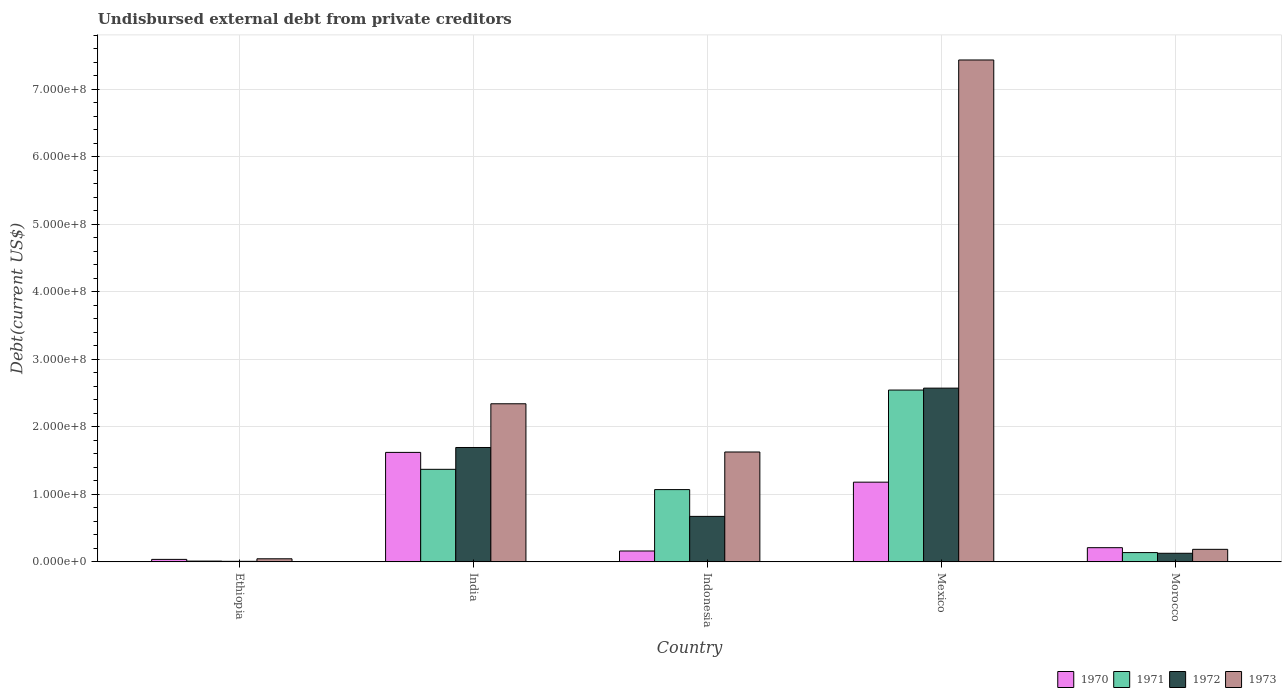How many different coloured bars are there?
Your answer should be very brief. 4. How many groups of bars are there?
Your response must be concise. 5. What is the label of the 5th group of bars from the left?
Your answer should be very brief. Morocco. In how many cases, is the number of bars for a given country not equal to the number of legend labels?
Your answer should be compact. 0. What is the total debt in 1970 in India?
Your answer should be very brief. 1.62e+08. Across all countries, what is the maximum total debt in 1970?
Your answer should be very brief. 1.62e+08. Across all countries, what is the minimum total debt in 1973?
Provide a short and direct response. 4.57e+06. In which country was the total debt in 1970 maximum?
Give a very brief answer. India. In which country was the total debt in 1970 minimum?
Provide a succinct answer. Ethiopia. What is the total total debt in 1970 in the graph?
Ensure brevity in your answer.  3.21e+08. What is the difference between the total debt in 1970 in India and that in Mexico?
Your answer should be very brief. 4.41e+07. What is the difference between the total debt in 1972 in Morocco and the total debt in 1970 in Indonesia?
Your response must be concise. -3.39e+06. What is the average total debt in 1971 per country?
Ensure brevity in your answer.  1.03e+08. What is the difference between the total debt of/in 1970 and total debt of/in 1971 in Morocco?
Make the answer very short. 7.27e+06. In how many countries, is the total debt in 1972 greater than 580000000 US$?
Offer a terse response. 0. What is the ratio of the total debt in 1970 in Ethiopia to that in Mexico?
Offer a very short reply. 0.03. Is the total debt in 1970 in Ethiopia less than that in Indonesia?
Your answer should be compact. Yes. Is the difference between the total debt in 1970 in India and Morocco greater than the difference between the total debt in 1971 in India and Morocco?
Give a very brief answer. Yes. What is the difference between the highest and the second highest total debt in 1970?
Give a very brief answer. -4.41e+07. What is the difference between the highest and the lowest total debt in 1971?
Offer a very short reply. 2.53e+08. In how many countries, is the total debt in 1973 greater than the average total debt in 1973 taken over all countries?
Your response must be concise. 2. Is the sum of the total debt in 1971 in Ethiopia and Morocco greater than the maximum total debt in 1973 across all countries?
Offer a very short reply. No. Is it the case that in every country, the sum of the total debt in 1970 and total debt in 1971 is greater than the sum of total debt in 1972 and total debt in 1973?
Give a very brief answer. No. What does the 2nd bar from the left in Ethiopia represents?
Ensure brevity in your answer.  1971. How many bars are there?
Ensure brevity in your answer.  20. Are all the bars in the graph horizontal?
Give a very brief answer. No. How many countries are there in the graph?
Offer a terse response. 5. What is the difference between two consecutive major ticks on the Y-axis?
Keep it short and to the point. 1.00e+08. Does the graph contain grids?
Offer a terse response. Yes. How are the legend labels stacked?
Provide a succinct answer. Horizontal. What is the title of the graph?
Provide a short and direct response. Undisbursed external debt from private creditors. Does "2010" appear as one of the legend labels in the graph?
Your response must be concise. No. What is the label or title of the Y-axis?
Your response must be concise. Debt(current US$). What is the Debt(current US$) in 1970 in Ethiopia?
Ensure brevity in your answer.  3.70e+06. What is the Debt(current US$) of 1971 in Ethiopia?
Provide a short and direct response. 1.16e+06. What is the Debt(current US$) in 1972 in Ethiopia?
Offer a terse response. 8.20e+05. What is the Debt(current US$) in 1973 in Ethiopia?
Offer a terse response. 4.57e+06. What is the Debt(current US$) of 1970 in India?
Make the answer very short. 1.62e+08. What is the Debt(current US$) of 1971 in India?
Provide a succinct answer. 1.37e+08. What is the Debt(current US$) in 1972 in India?
Offer a terse response. 1.69e+08. What is the Debt(current US$) in 1973 in India?
Your answer should be compact. 2.34e+08. What is the Debt(current US$) of 1970 in Indonesia?
Provide a short and direct response. 1.61e+07. What is the Debt(current US$) of 1971 in Indonesia?
Your answer should be very brief. 1.07e+08. What is the Debt(current US$) of 1972 in Indonesia?
Give a very brief answer. 6.74e+07. What is the Debt(current US$) in 1973 in Indonesia?
Offer a terse response. 1.63e+08. What is the Debt(current US$) in 1970 in Mexico?
Give a very brief answer. 1.18e+08. What is the Debt(current US$) in 1971 in Mexico?
Keep it short and to the point. 2.54e+08. What is the Debt(current US$) in 1972 in Mexico?
Your answer should be very brief. 2.57e+08. What is the Debt(current US$) in 1973 in Mexico?
Your answer should be very brief. 7.43e+08. What is the Debt(current US$) in 1970 in Morocco?
Offer a very short reply. 2.10e+07. What is the Debt(current US$) in 1971 in Morocco?
Ensure brevity in your answer.  1.37e+07. What is the Debt(current US$) of 1972 in Morocco?
Keep it short and to the point. 1.27e+07. What is the Debt(current US$) in 1973 in Morocco?
Your response must be concise. 1.86e+07. Across all countries, what is the maximum Debt(current US$) of 1970?
Keep it short and to the point. 1.62e+08. Across all countries, what is the maximum Debt(current US$) of 1971?
Your response must be concise. 2.54e+08. Across all countries, what is the maximum Debt(current US$) in 1972?
Provide a succinct answer. 2.57e+08. Across all countries, what is the maximum Debt(current US$) of 1973?
Offer a terse response. 7.43e+08. Across all countries, what is the minimum Debt(current US$) of 1970?
Your answer should be very brief. 3.70e+06. Across all countries, what is the minimum Debt(current US$) of 1971?
Provide a short and direct response. 1.16e+06. Across all countries, what is the minimum Debt(current US$) of 1972?
Offer a very short reply. 8.20e+05. Across all countries, what is the minimum Debt(current US$) in 1973?
Provide a short and direct response. 4.57e+06. What is the total Debt(current US$) in 1970 in the graph?
Offer a terse response. 3.21e+08. What is the total Debt(current US$) of 1971 in the graph?
Provide a succinct answer. 5.13e+08. What is the total Debt(current US$) in 1972 in the graph?
Your answer should be compact. 5.08e+08. What is the total Debt(current US$) in 1973 in the graph?
Make the answer very short. 1.16e+09. What is the difference between the Debt(current US$) of 1970 in Ethiopia and that in India?
Your response must be concise. -1.58e+08. What is the difference between the Debt(current US$) in 1971 in Ethiopia and that in India?
Keep it short and to the point. -1.36e+08. What is the difference between the Debt(current US$) of 1972 in Ethiopia and that in India?
Your response must be concise. -1.69e+08. What is the difference between the Debt(current US$) in 1973 in Ethiopia and that in India?
Make the answer very short. -2.30e+08. What is the difference between the Debt(current US$) of 1970 in Ethiopia and that in Indonesia?
Give a very brief answer. -1.24e+07. What is the difference between the Debt(current US$) of 1971 in Ethiopia and that in Indonesia?
Keep it short and to the point. -1.06e+08. What is the difference between the Debt(current US$) in 1972 in Ethiopia and that in Indonesia?
Offer a terse response. -6.66e+07. What is the difference between the Debt(current US$) in 1973 in Ethiopia and that in Indonesia?
Offer a very short reply. -1.58e+08. What is the difference between the Debt(current US$) in 1970 in Ethiopia and that in Mexico?
Your response must be concise. -1.14e+08. What is the difference between the Debt(current US$) of 1971 in Ethiopia and that in Mexico?
Offer a terse response. -2.53e+08. What is the difference between the Debt(current US$) in 1972 in Ethiopia and that in Mexico?
Offer a very short reply. -2.56e+08. What is the difference between the Debt(current US$) of 1973 in Ethiopia and that in Mexico?
Provide a short and direct response. -7.39e+08. What is the difference between the Debt(current US$) of 1970 in Ethiopia and that in Morocco?
Ensure brevity in your answer.  -1.73e+07. What is the difference between the Debt(current US$) of 1971 in Ethiopia and that in Morocco?
Your answer should be compact. -1.26e+07. What is the difference between the Debt(current US$) of 1972 in Ethiopia and that in Morocco?
Your response must be concise. -1.19e+07. What is the difference between the Debt(current US$) of 1973 in Ethiopia and that in Morocco?
Make the answer very short. -1.40e+07. What is the difference between the Debt(current US$) of 1970 in India and that in Indonesia?
Offer a very short reply. 1.46e+08. What is the difference between the Debt(current US$) of 1971 in India and that in Indonesia?
Provide a succinct answer. 3.00e+07. What is the difference between the Debt(current US$) of 1972 in India and that in Indonesia?
Your answer should be compact. 1.02e+08. What is the difference between the Debt(current US$) of 1973 in India and that in Indonesia?
Make the answer very short. 7.14e+07. What is the difference between the Debt(current US$) of 1970 in India and that in Mexico?
Your answer should be compact. 4.41e+07. What is the difference between the Debt(current US$) in 1971 in India and that in Mexico?
Provide a succinct answer. -1.17e+08. What is the difference between the Debt(current US$) in 1972 in India and that in Mexico?
Your answer should be compact. -8.79e+07. What is the difference between the Debt(current US$) of 1973 in India and that in Mexico?
Give a very brief answer. -5.09e+08. What is the difference between the Debt(current US$) of 1970 in India and that in Morocco?
Offer a terse response. 1.41e+08. What is the difference between the Debt(current US$) of 1971 in India and that in Morocco?
Ensure brevity in your answer.  1.23e+08. What is the difference between the Debt(current US$) of 1972 in India and that in Morocco?
Your answer should be compact. 1.57e+08. What is the difference between the Debt(current US$) of 1973 in India and that in Morocco?
Ensure brevity in your answer.  2.16e+08. What is the difference between the Debt(current US$) of 1970 in Indonesia and that in Mexico?
Give a very brief answer. -1.02e+08. What is the difference between the Debt(current US$) in 1971 in Indonesia and that in Mexico?
Offer a very short reply. -1.47e+08. What is the difference between the Debt(current US$) of 1972 in Indonesia and that in Mexico?
Keep it short and to the point. -1.90e+08. What is the difference between the Debt(current US$) in 1973 in Indonesia and that in Mexico?
Your response must be concise. -5.81e+08. What is the difference between the Debt(current US$) in 1970 in Indonesia and that in Morocco?
Provide a short and direct response. -4.89e+06. What is the difference between the Debt(current US$) in 1971 in Indonesia and that in Morocco?
Your answer should be very brief. 9.33e+07. What is the difference between the Debt(current US$) in 1972 in Indonesia and that in Morocco?
Ensure brevity in your answer.  5.46e+07. What is the difference between the Debt(current US$) in 1973 in Indonesia and that in Morocco?
Keep it short and to the point. 1.44e+08. What is the difference between the Debt(current US$) in 1970 in Mexico and that in Morocco?
Your answer should be very brief. 9.70e+07. What is the difference between the Debt(current US$) of 1971 in Mexico and that in Morocco?
Offer a terse response. 2.41e+08. What is the difference between the Debt(current US$) of 1972 in Mexico and that in Morocco?
Provide a short and direct response. 2.45e+08. What is the difference between the Debt(current US$) of 1973 in Mexico and that in Morocco?
Give a very brief answer. 7.25e+08. What is the difference between the Debt(current US$) of 1970 in Ethiopia and the Debt(current US$) of 1971 in India?
Your answer should be compact. -1.33e+08. What is the difference between the Debt(current US$) of 1970 in Ethiopia and the Debt(current US$) of 1972 in India?
Provide a short and direct response. -1.66e+08. What is the difference between the Debt(current US$) in 1970 in Ethiopia and the Debt(current US$) in 1973 in India?
Offer a terse response. -2.30e+08. What is the difference between the Debt(current US$) in 1971 in Ethiopia and the Debt(current US$) in 1972 in India?
Make the answer very short. -1.68e+08. What is the difference between the Debt(current US$) of 1971 in Ethiopia and the Debt(current US$) of 1973 in India?
Your response must be concise. -2.33e+08. What is the difference between the Debt(current US$) of 1972 in Ethiopia and the Debt(current US$) of 1973 in India?
Offer a terse response. -2.33e+08. What is the difference between the Debt(current US$) in 1970 in Ethiopia and the Debt(current US$) in 1971 in Indonesia?
Ensure brevity in your answer.  -1.03e+08. What is the difference between the Debt(current US$) in 1970 in Ethiopia and the Debt(current US$) in 1972 in Indonesia?
Ensure brevity in your answer.  -6.37e+07. What is the difference between the Debt(current US$) of 1970 in Ethiopia and the Debt(current US$) of 1973 in Indonesia?
Offer a very short reply. -1.59e+08. What is the difference between the Debt(current US$) of 1971 in Ethiopia and the Debt(current US$) of 1972 in Indonesia?
Give a very brief answer. -6.62e+07. What is the difference between the Debt(current US$) in 1971 in Ethiopia and the Debt(current US$) in 1973 in Indonesia?
Provide a succinct answer. -1.62e+08. What is the difference between the Debt(current US$) in 1972 in Ethiopia and the Debt(current US$) in 1973 in Indonesia?
Provide a succinct answer. -1.62e+08. What is the difference between the Debt(current US$) of 1970 in Ethiopia and the Debt(current US$) of 1971 in Mexico?
Your answer should be compact. -2.51e+08. What is the difference between the Debt(current US$) in 1970 in Ethiopia and the Debt(current US$) in 1972 in Mexico?
Your response must be concise. -2.54e+08. What is the difference between the Debt(current US$) in 1970 in Ethiopia and the Debt(current US$) in 1973 in Mexico?
Provide a short and direct response. -7.40e+08. What is the difference between the Debt(current US$) in 1971 in Ethiopia and the Debt(current US$) in 1972 in Mexico?
Your response must be concise. -2.56e+08. What is the difference between the Debt(current US$) in 1971 in Ethiopia and the Debt(current US$) in 1973 in Mexico?
Keep it short and to the point. -7.42e+08. What is the difference between the Debt(current US$) in 1972 in Ethiopia and the Debt(current US$) in 1973 in Mexico?
Ensure brevity in your answer.  -7.42e+08. What is the difference between the Debt(current US$) in 1970 in Ethiopia and the Debt(current US$) in 1971 in Morocco?
Offer a terse response. -1.01e+07. What is the difference between the Debt(current US$) in 1970 in Ethiopia and the Debt(current US$) in 1972 in Morocco?
Your answer should be very brief. -9.04e+06. What is the difference between the Debt(current US$) in 1970 in Ethiopia and the Debt(current US$) in 1973 in Morocco?
Make the answer very short. -1.49e+07. What is the difference between the Debt(current US$) in 1971 in Ethiopia and the Debt(current US$) in 1972 in Morocco?
Ensure brevity in your answer.  -1.16e+07. What is the difference between the Debt(current US$) of 1971 in Ethiopia and the Debt(current US$) of 1973 in Morocco?
Offer a very short reply. -1.74e+07. What is the difference between the Debt(current US$) in 1972 in Ethiopia and the Debt(current US$) in 1973 in Morocco?
Offer a very short reply. -1.77e+07. What is the difference between the Debt(current US$) in 1970 in India and the Debt(current US$) in 1971 in Indonesia?
Offer a very short reply. 5.51e+07. What is the difference between the Debt(current US$) of 1970 in India and the Debt(current US$) of 1972 in Indonesia?
Offer a very short reply. 9.47e+07. What is the difference between the Debt(current US$) of 1970 in India and the Debt(current US$) of 1973 in Indonesia?
Keep it short and to the point. -5.84e+05. What is the difference between the Debt(current US$) of 1971 in India and the Debt(current US$) of 1972 in Indonesia?
Ensure brevity in your answer.  6.97e+07. What is the difference between the Debt(current US$) of 1971 in India and the Debt(current US$) of 1973 in Indonesia?
Make the answer very short. -2.56e+07. What is the difference between the Debt(current US$) in 1972 in India and the Debt(current US$) in 1973 in Indonesia?
Your answer should be very brief. 6.68e+06. What is the difference between the Debt(current US$) of 1970 in India and the Debt(current US$) of 1971 in Mexico?
Make the answer very short. -9.23e+07. What is the difference between the Debt(current US$) of 1970 in India and the Debt(current US$) of 1972 in Mexico?
Your answer should be very brief. -9.51e+07. What is the difference between the Debt(current US$) of 1970 in India and the Debt(current US$) of 1973 in Mexico?
Your answer should be very brief. -5.81e+08. What is the difference between the Debt(current US$) of 1971 in India and the Debt(current US$) of 1972 in Mexico?
Offer a terse response. -1.20e+08. What is the difference between the Debt(current US$) in 1971 in India and the Debt(current US$) in 1973 in Mexico?
Your answer should be compact. -6.06e+08. What is the difference between the Debt(current US$) in 1972 in India and the Debt(current US$) in 1973 in Mexico?
Provide a short and direct response. -5.74e+08. What is the difference between the Debt(current US$) of 1970 in India and the Debt(current US$) of 1971 in Morocco?
Your answer should be very brief. 1.48e+08. What is the difference between the Debt(current US$) in 1970 in India and the Debt(current US$) in 1972 in Morocco?
Provide a succinct answer. 1.49e+08. What is the difference between the Debt(current US$) in 1970 in India and the Debt(current US$) in 1973 in Morocco?
Offer a very short reply. 1.44e+08. What is the difference between the Debt(current US$) of 1971 in India and the Debt(current US$) of 1972 in Morocco?
Ensure brevity in your answer.  1.24e+08. What is the difference between the Debt(current US$) of 1971 in India and the Debt(current US$) of 1973 in Morocco?
Make the answer very short. 1.19e+08. What is the difference between the Debt(current US$) in 1972 in India and the Debt(current US$) in 1973 in Morocco?
Offer a very short reply. 1.51e+08. What is the difference between the Debt(current US$) in 1970 in Indonesia and the Debt(current US$) in 1971 in Mexico?
Give a very brief answer. -2.38e+08. What is the difference between the Debt(current US$) in 1970 in Indonesia and the Debt(current US$) in 1972 in Mexico?
Give a very brief answer. -2.41e+08. What is the difference between the Debt(current US$) of 1970 in Indonesia and the Debt(current US$) of 1973 in Mexico?
Ensure brevity in your answer.  -7.27e+08. What is the difference between the Debt(current US$) of 1971 in Indonesia and the Debt(current US$) of 1972 in Mexico?
Provide a short and direct response. -1.50e+08. What is the difference between the Debt(current US$) in 1971 in Indonesia and the Debt(current US$) in 1973 in Mexico?
Your response must be concise. -6.36e+08. What is the difference between the Debt(current US$) of 1972 in Indonesia and the Debt(current US$) of 1973 in Mexico?
Your response must be concise. -6.76e+08. What is the difference between the Debt(current US$) of 1970 in Indonesia and the Debt(current US$) of 1971 in Morocco?
Offer a terse response. 2.38e+06. What is the difference between the Debt(current US$) in 1970 in Indonesia and the Debt(current US$) in 1972 in Morocco?
Your answer should be compact. 3.39e+06. What is the difference between the Debt(current US$) in 1970 in Indonesia and the Debt(current US$) in 1973 in Morocco?
Keep it short and to the point. -2.44e+06. What is the difference between the Debt(current US$) of 1971 in Indonesia and the Debt(current US$) of 1972 in Morocco?
Offer a terse response. 9.43e+07. What is the difference between the Debt(current US$) in 1971 in Indonesia and the Debt(current US$) in 1973 in Morocco?
Ensure brevity in your answer.  8.85e+07. What is the difference between the Debt(current US$) of 1972 in Indonesia and the Debt(current US$) of 1973 in Morocco?
Make the answer very short. 4.88e+07. What is the difference between the Debt(current US$) in 1970 in Mexico and the Debt(current US$) in 1971 in Morocco?
Offer a very short reply. 1.04e+08. What is the difference between the Debt(current US$) of 1970 in Mexico and the Debt(current US$) of 1972 in Morocco?
Your answer should be compact. 1.05e+08. What is the difference between the Debt(current US$) of 1970 in Mexico and the Debt(current US$) of 1973 in Morocco?
Provide a short and direct response. 9.95e+07. What is the difference between the Debt(current US$) in 1971 in Mexico and the Debt(current US$) in 1972 in Morocco?
Your answer should be compact. 2.42e+08. What is the difference between the Debt(current US$) of 1971 in Mexico and the Debt(current US$) of 1973 in Morocco?
Make the answer very short. 2.36e+08. What is the difference between the Debt(current US$) of 1972 in Mexico and the Debt(current US$) of 1973 in Morocco?
Ensure brevity in your answer.  2.39e+08. What is the average Debt(current US$) in 1970 per country?
Ensure brevity in your answer.  6.42e+07. What is the average Debt(current US$) in 1971 per country?
Make the answer very short. 1.03e+08. What is the average Debt(current US$) in 1972 per country?
Ensure brevity in your answer.  1.02e+08. What is the average Debt(current US$) of 1973 per country?
Your answer should be compact. 2.33e+08. What is the difference between the Debt(current US$) in 1970 and Debt(current US$) in 1971 in Ethiopia?
Ensure brevity in your answer.  2.53e+06. What is the difference between the Debt(current US$) in 1970 and Debt(current US$) in 1972 in Ethiopia?
Your answer should be very brief. 2.88e+06. What is the difference between the Debt(current US$) of 1970 and Debt(current US$) of 1973 in Ethiopia?
Your answer should be very brief. -8.70e+05. What is the difference between the Debt(current US$) of 1971 and Debt(current US$) of 1972 in Ethiopia?
Provide a succinct answer. 3.45e+05. What is the difference between the Debt(current US$) in 1971 and Debt(current US$) in 1973 in Ethiopia?
Give a very brief answer. -3.40e+06. What is the difference between the Debt(current US$) of 1972 and Debt(current US$) of 1973 in Ethiopia?
Provide a short and direct response. -3.75e+06. What is the difference between the Debt(current US$) in 1970 and Debt(current US$) in 1971 in India?
Offer a terse response. 2.51e+07. What is the difference between the Debt(current US$) in 1970 and Debt(current US$) in 1972 in India?
Offer a very short reply. -7.26e+06. What is the difference between the Debt(current US$) of 1970 and Debt(current US$) of 1973 in India?
Offer a very short reply. -7.20e+07. What is the difference between the Debt(current US$) of 1971 and Debt(current US$) of 1972 in India?
Your answer should be compact. -3.23e+07. What is the difference between the Debt(current US$) in 1971 and Debt(current US$) in 1973 in India?
Ensure brevity in your answer.  -9.70e+07. What is the difference between the Debt(current US$) in 1972 and Debt(current US$) in 1973 in India?
Ensure brevity in your answer.  -6.47e+07. What is the difference between the Debt(current US$) in 1970 and Debt(current US$) in 1971 in Indonesia?
Your answer should be very brief. -9.09e+07. What is the difference between the Debt(current US$) in 1970 and Debt(current US$) in 1972 in Indonesia?
Provide a short and direct response. -5.12e+07. What is the difference between the Debt(current US$) in 1970 and Debt(current US$) in 1973 in Indonesia?
Your response must be concise. -1.47e+08. What is the difference between the Debt(current US$) of 1971 and Debt(current US$) of 1972 in Indonesia?
Offer a very short reply. 3.96e+07. What is the difference between the Debt(current US$) of 1971 and Debt(current US$) of 1973 in Indonesia?
Give a very brief answer. -5.57e+07. What is the difference between the Debt(current US$) of 1972 and Debt(current US$) of 1973 in Indonesia?
Make the answer very short. -9.53e+07. What is the difference between the Debt(current US$) in 1970 and Debt(current US$) in 1971 in Mexico?
Offer a very short reply. -1.36e+08. What is the difference between the Debt(current US$) of 1970 and Debt(current US$) of 1972 in Mexico?
Provide a short and direct response. -1.39e+08. What is the difference between the Debt(current US$) of 1970 and Debt(current US$) of 1973 in Mexico?
Keep it short and to the point. -6.25e+08. What is the difference between the Debt(current US$) of 1971 and Debt(current US$) of 1972 in Mexico?
Provide a succinct answer. -2.84e+06. What is the difference between the Debt(current US$) of 1971 and Debt(current US$) of 1973 in Mexico?
Provide a succinct answer. -4.89e+08. What is the difference between the Debt(current US$) of 1972 and Debt(current US$) of 1973 in Mexico?
Provide a short and direct response. -4.86e+08. What is the difference between the Debt(current US$) of 1970 and Debt(current US$) of 1971 in Morocco?
Make the answer very short. 7.27e+06. What is the difference between the Debt(current US$) of 1970 and Debt(current US$) of 1972 in Morocco?
Offer a terse response. 8.28e+06. What is the difference between the Debt(current US$) in 1970 and Debt(current US$) in 1973 in Morocco?
Ensure brevity in your answer.  2.45e+06. What is the difference between the Debt(current US$) of 1971 and Debt(current US$) of 1972 in Morocco?
Make the answer very short. 1.01e+06. What is the difference between the Debt(current US$) of 1971 and Debt(current US$) of 1973 in Morocco?
Ensure brevity in your answer.  -4.81e+06. What is the difference between the Debt(current US$) of 1972 and Debt(current US$) of 1973 in Morocco?
Your response must be concise. -5.82e+06. What is the ratio of the Debt(current US$) of 1970 in Ethiopia to that in India?
Your response must be concise. 0.02. What is the ratio of the Debt(current US$) in 1971 in Ethiopia to that in India?
Your response must be concise. 0.01. What is the ratio of the Debt(current US$) in 1972 in Ethiopia to that in India?
Your answer should be compact. 0. What is the ratio of the Debt(current US$) of 1973 in Ethiopia to that in India?
Give a very brief answer. 0.02. What is the ratio of the Debt(current US$) of 1970 in Ethiopia to that in Indonesia?
Provide a succinct answer. 0.23. What is the ratio of the Debt(current US$) in 1971 in Ethiopia to that in Indonesia?
Offer a very short reply. 0.01. What is the ratio of the Debt(current US$) in 1972 in Ethiopia to that in Indonesia?
Provide a short and direct response. 0.01. What is the ratio of the Debt(current US$) of 1973 in Ethiopia to that in Indonesia?
Make the answer very short. 0.03. What is the ratio of the Debt(current US$) of 1970 in Ethiopia to that in Mexico?
Make the answer very short. 0.03. What is the ratio of the Debt(current US$) in 1971 in Ethiopia to that in Mexico?
Give a very brief answer. 0. What is the ratio of the Debt(current US$) of 1972 in Ethiopia to that in Mexico?
Give a very brief answer. 0. What is the ratio of the Debt(current US$) of 1973 in Ethiopia to that in Mexico?
Your answer should be very brief. 0.01. What is the ratio of the Debt(current US$) in 1970 in Ethiopia to that in Morocco?
Your answer should be compact. 0.18. What is the ratio of the Debt(current US$) of 1971 in Ethiopia to that in Morocco?
Provide a succinct answer. 0.08. What is the ratio of the Debt(current US$) in 1972 in Ethiopia to that in Morocco?
Your answer should be compact. 0.06. What is the ratio of the Debt(current US$) of 1973 in Ethiopia to that in Morocco?
Offer a very short reply. 0.25. What is the ratio of the Debt(current US$) in 1970 in India to that in Indonesia?
Your answer should be very brief. 10.05. What is the ratio of the Debt(current US$) in 1971 in India to that in Indonesia?
Offer a terse response. 1.28. What is the ratio of the Debt(current US$) of 1972 in India to that in Indonesia?
Offer a terse response. 2.51. What is the ratio of the Debt(current US$) in 1973 in India to that in Indonesia?
Your answer should be compact. 1.44. What is the ratio of the Debt(current US$) in 1970 in India to that in Mexico?
Your answer should be very brief. 1.37. What is the ratio of the Debt(current US$) in 1971 in India to that in Mexico?
Keep it short and to the point. 0.54. What is the ratio of the Debt(current US$) of 1972 in India to that in Mexico?
Provide a short and direct response. 0.66. What is the ratio of the Debt(current US$) of 1973 in India to that in Mexico?
Keep it short and to the point. 0.32. What is the ratio of the Debt(current US$) of 1970 in India to that in Morocco?
Offer a terse response. 7.71. What is the ratio of the Debt(current US$) of 1971 in India to that in Morocco?
Make the answer very short. 9.97. What is the ratio of the Debt(current US$) in 1972 in India to that in Morocco?
Your answer should be very brief. 13.3. What is the ratio of the Debt(current US$) in 1973 in India to that in Morocco?
Your response must be concise. 12.61. What is the ratio of the Debt(current US$) in 1970 in Indonesia to that in Mexico?
Offer a very short reply. 0.14. What is the ratio of the Debt(current US$) of 1971 in Indonesia to that in Mexico?
Provide a short and direct response. 0.42. What is the ratio of the Debt(current US$) of 1972 in Indonesia to that in Mexico?
Your response must be concise. 0.26. What is the ratio of the Debt(current US$) in 1973 in Indonesia to that in Mexico?
Your answer should be compact. 0.22. What is the ratio of the Debt(current US$) of 1970 in Indonesia to that in Morocco?
Provide a short and direct response. 0.77. What is the ratio of the Debt(current US$) in 1971 in Indonesia to that in Morocco?
Ensure brevity in your answer.  7.78. What is the ratio of the Debt(current US$) in 1972 in Indonesia to that in Morocco?
Ensure brevity in your answer.  5.29. What is the ratio of the Debt(current US$) in 1973 in Indonesia to that in Morocco?
Provide a short and direct response. 8.77. What is the ratio of the Debt(current US$) of 1970 in Mexico to that in Morocco?
Your answer should be very brief. 5.62. What is the ratio of the Debt(current US$) in 1971 in Mexico to that in Morocco?
Your answer should be very brief. 18.51. What is the ratio of the Debt(current US$) of 1972 in Mexico to that in Morocco?
Keep it short and to the point. 20.2. What is the ratio of the Debt(current US$) in 1973 in Mexico to that in Morocco?
Offer a terse response. 40.04. What is the difference between the highest and the second highest Debt(current US$) in 1970?
Your answer should be compact. 4.41e+07. What is the difference between the highest and the second highest Debt(current US$) in 1971?
Your answer should be very brief. 1.17e+08. What is the difference between the highest and the second highest Debt(current US$) in 1972?
Your response must be concise. 8.79e+07. What is the difference between the highest and the second highest Debt(current US$) of 1973?
Keep it short and to the point. 5.09e+08. What is the difference between the highest and the lowest Debt(current US$) in 1970?
Provide a succinct answer. 1.58e+08. What is the difference between the highest and the lowest Debt(current US$) of 1971?
Your answer should be very brief. 2.53e+08. What is the difference between the highest and the lowest Debt(current US$) of 1972?
Offer a terse response. 2.56e+08. What is the difference between the highest and the lowest Debt(current US$) of 1973?
Make the answer very short. 7.39e+08. 